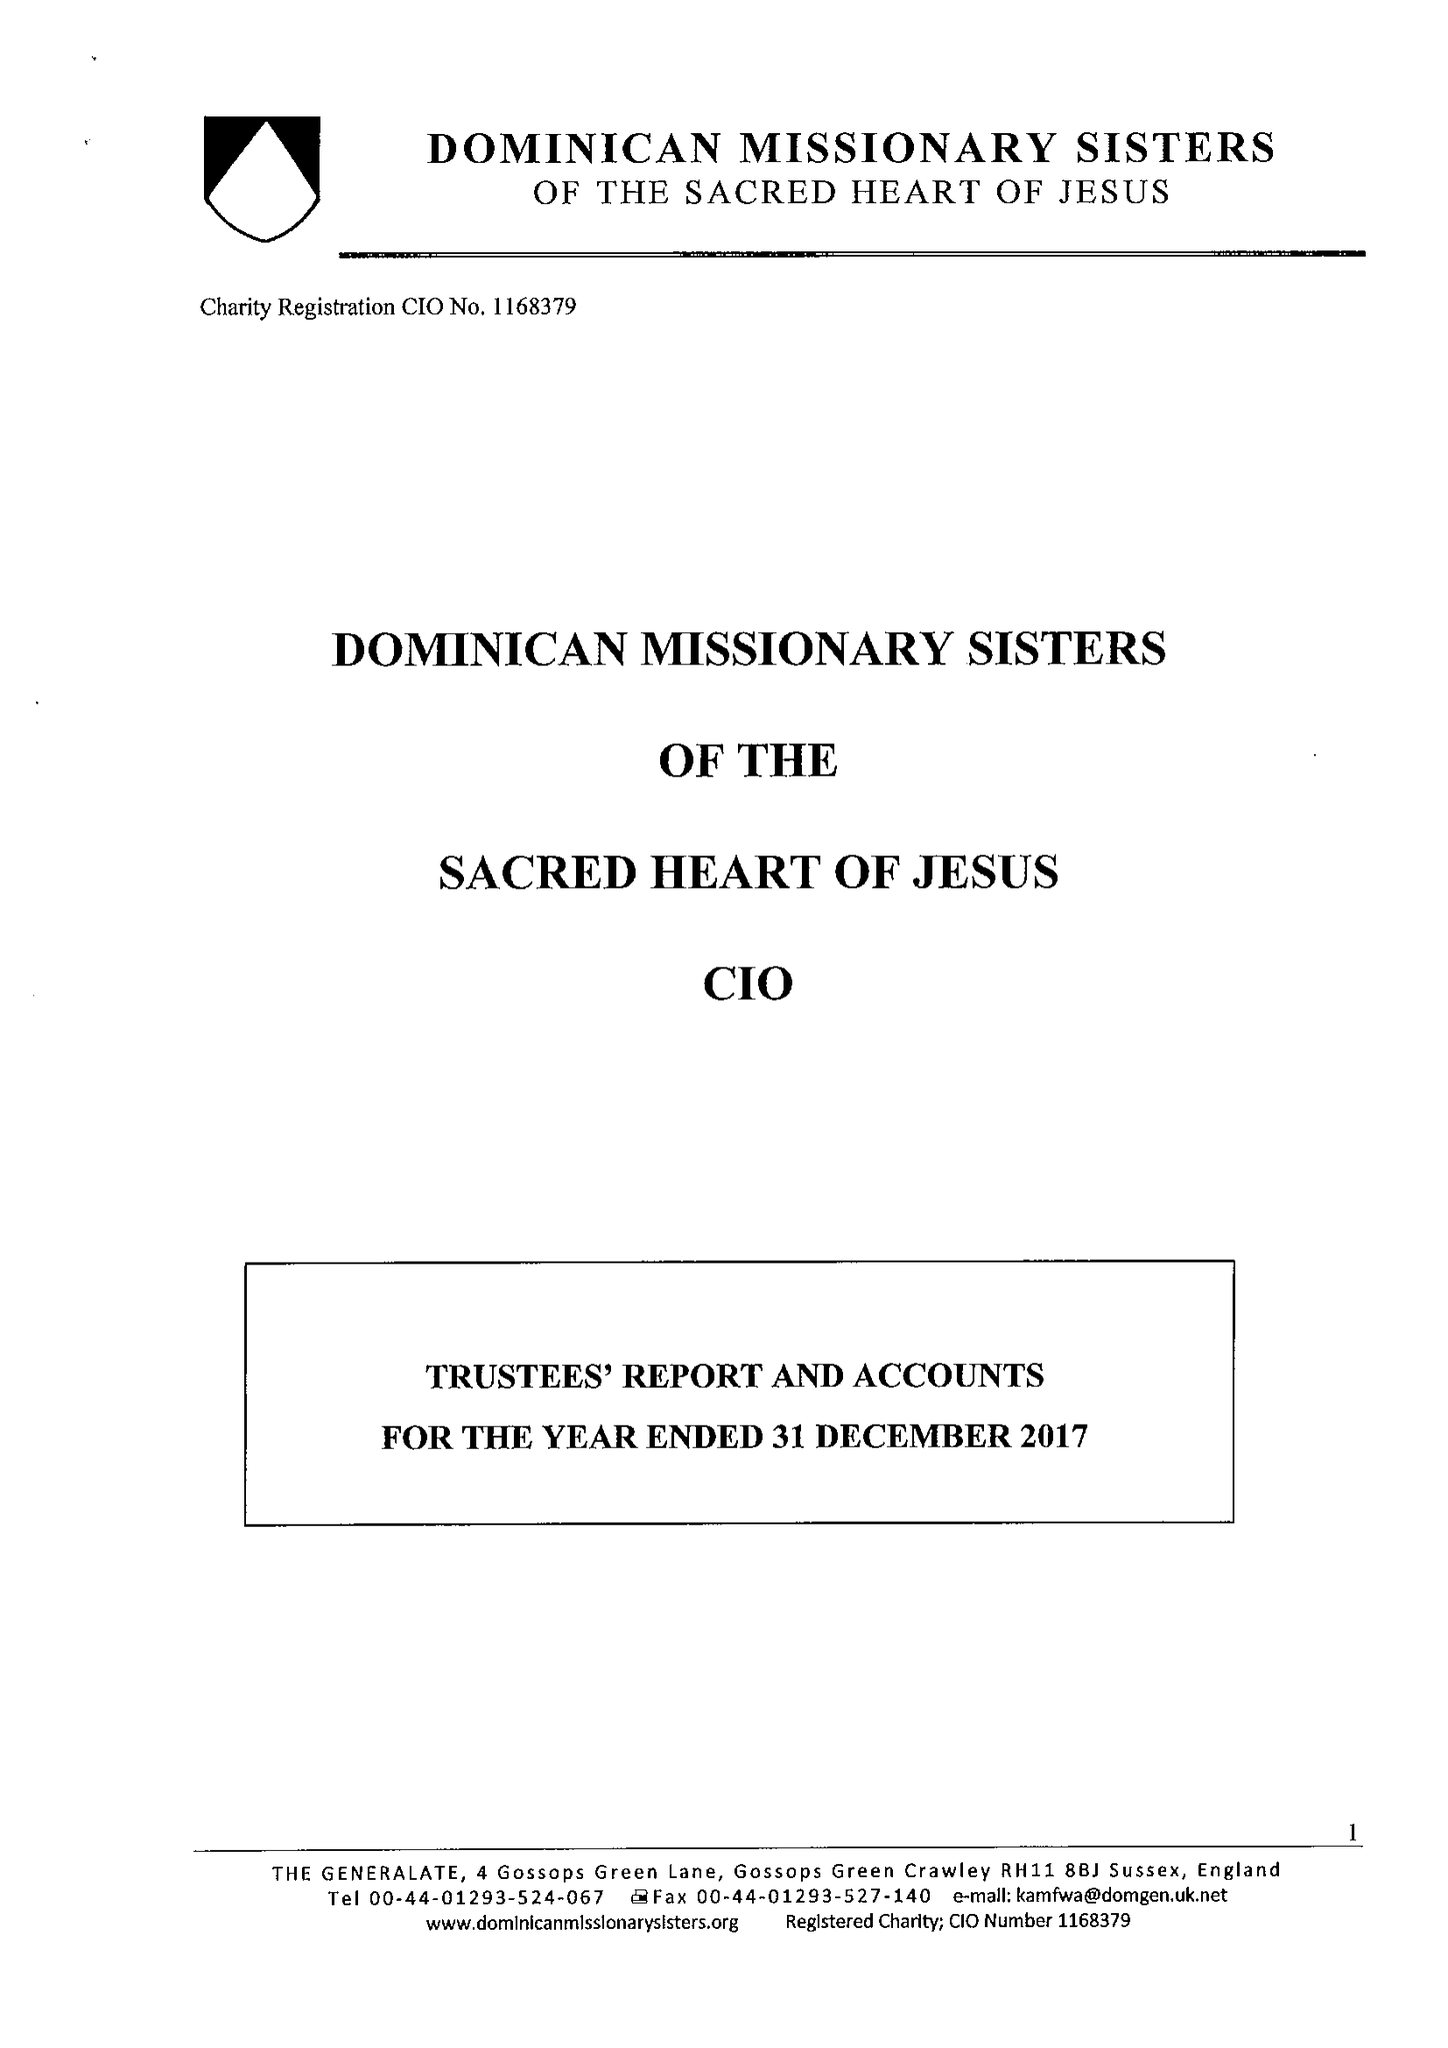What is the value for the address__postcode?
Answer the question using a single word or phrase. RH11 8BJ 